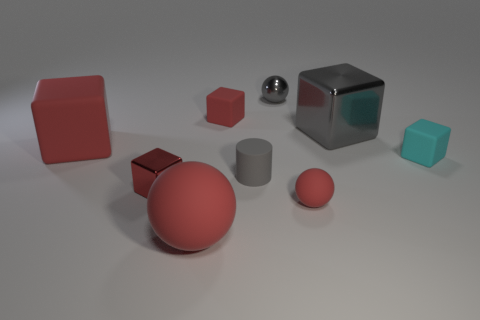There is a gray block; is its size the same as the gray shiny object that is to the left of the small matte sphere?
Your answer should be compact. No. Is the number of matte balls behind the small metallic ball the same as the number of tiny brown matte cubes?
Ensure brevity in your answer.  Yes. There is a gray ball that is behind the big cube on the left side of the tiny gray rubber thing; how many tiny gray metallic objects are behind it?
Provide a succinct answer. 0. Is there a red sphere of the same size as the gray metal cube?
Provide a short and direct response. Yes. Are there fewer large red spheres that are behind the tiny cyan matte cube than big red matte blocks?
Make the answer very short. Yes. The red sphere that is right of the small rubber object that is behind the big red rubber thing that is behind the big matte sphere is made of what material?
Give a very brief answer. Rubber. Are there more large cubes in front of the big gray thing than big rubber objects that are in front of the tiny cyan block?
Offer a very short reply. No. What number of rubber things are either large green cylinders or gray blocks?
Keep it short and to the point. 0. There is a large thing that is the same color as the large matte ball; what is its shape?
Keep it short and to the point. Cube. What material is the tiny red block that is in front of the small gray cylinder?
Make the answer very short. Metal. 